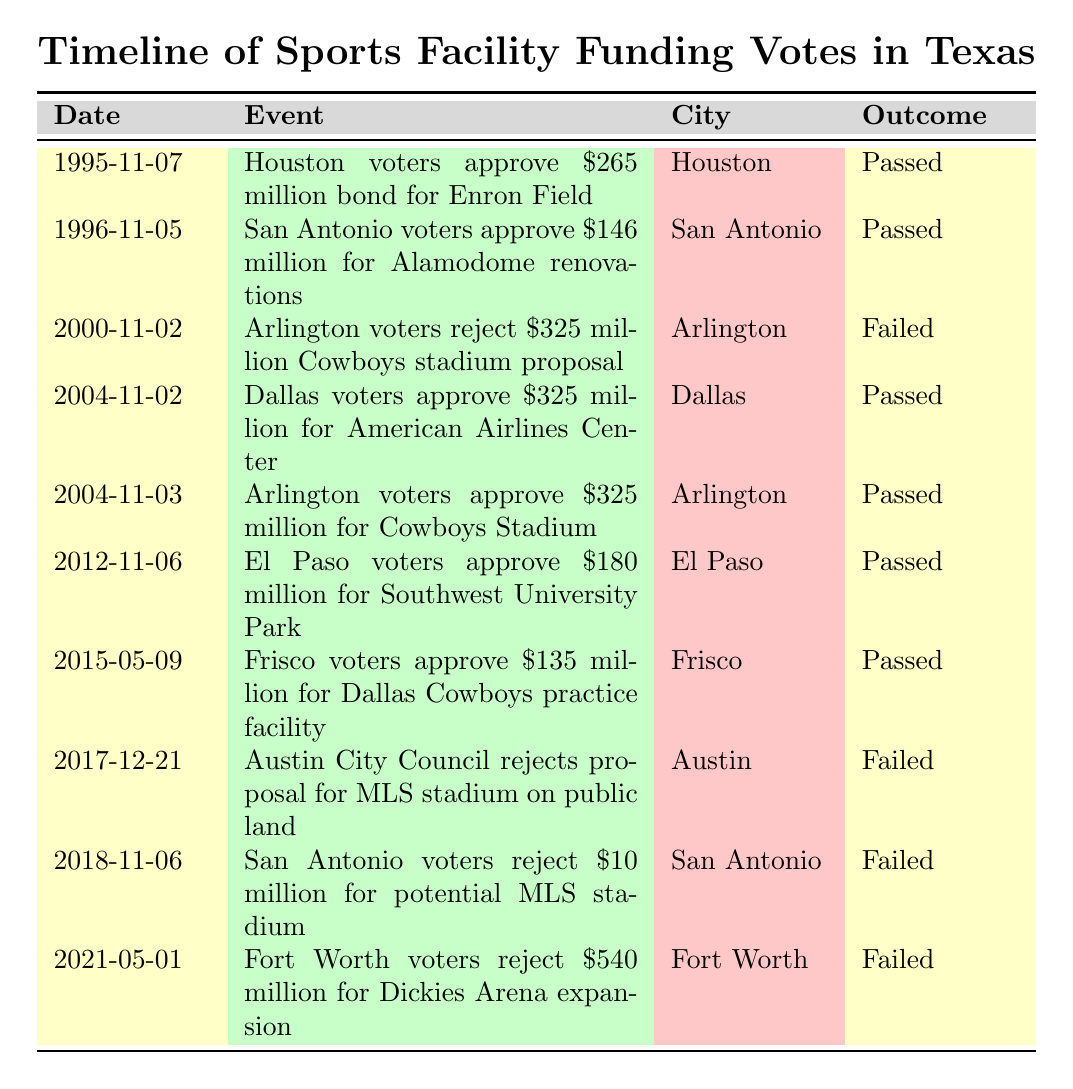What was the outcome of the vote for the Cowboys stadium in Arlington in 2004? The table shows that Arlington voters approved a $325 million proposal for Cowboys Stadium on November 3, 2004. The outcome listed is "Passed."
Answer: Passed How many proposals were rejected in San Antonio? The table lists two proposals rejected by San Antonio: the first for $10 million for a potential MLS stadium on November 6, 2018, and the second for renovations to Alamodome (though it was approved, it was highly controversial). Therefore, only one proposal rejection is noted in the table.
Answer: One What is the total amount approved for sports facilities in Houston and Dallas? In the table, Houston approved $265 million for Enron Field, and Dallas approved $325 million for the American Airlines Center. The total amount is calculated as follows: 265 + 325 = 590 million.
Answer: 590 million Did any city reject a proposal for a sports facility after 2015? According to the table, the last rejected proposal listed was from Fort Worth on May 1, 2021, where voters rejected a $540 million expansion for Dickies Arena. Therefore, the answer to whether any city rejected a proposal after 2015 is yes.
Answer: Yes What was the public reaction to the approval of the $180 million Southwest University Park in El Paso? The table indicates that the public reaction to the approval of $180 million for Southwest University Park in El Paso was concerns about prioritizing sports over other needs.
Answer: Concerns about prioritizing sports over other needs How many total approvals are there for sports facilities in Texas cities listed in the table? The table has a total of seven approvals out of the total ten events listed. By counting the rows marked "Passed," we find seven approvals: Houston, San Antonio, Dallas, Arlington (twice), El Paso, and Frisco.
Answer: Seven Which city had the most contentious public debate regarding sports facility funding? The table notes that both the proposal for Cowboys Stadium in Arlington and for the American Airlines Center in Dallas were contentious. However, Arlington's proposal had scrutiny over direct public funding, making it particularly contentious.
Answer: Arlington Was there a proposal that had strong opposition to increased property taxes? The table indicates that in Fort Worth, voters rejected a $540 million Dickies Arena expansion proposal on May 1, 2021, due to strong opposition to increased property taxes.
Answer: Yes 